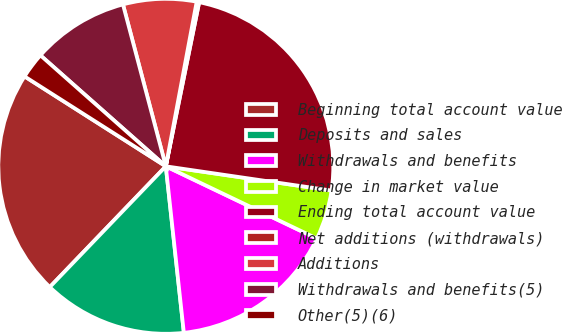Convert chart. <chart><loc_0><loc_0><loc_500><loc_500><pie_chart><fcel>Beginning total account value<fcel>Deposits and sales<fcel>Withdrawals and benefits<fcel>Change in market value<fcel>Ending total account value<fcel>Net additions (withdrawals)<fcel>Additions<fcel>Withdrawals and benefits(5)<fcel>Other(5)(6)<nl><fcel>21.84%<fcel>13.9%<fcel>16.18%<fcel>4.79%<fcel>24.12%<fcel>0.24%<fcel>7.07%<fcel>9.35%<fcel>2.51%<nl></chart> 